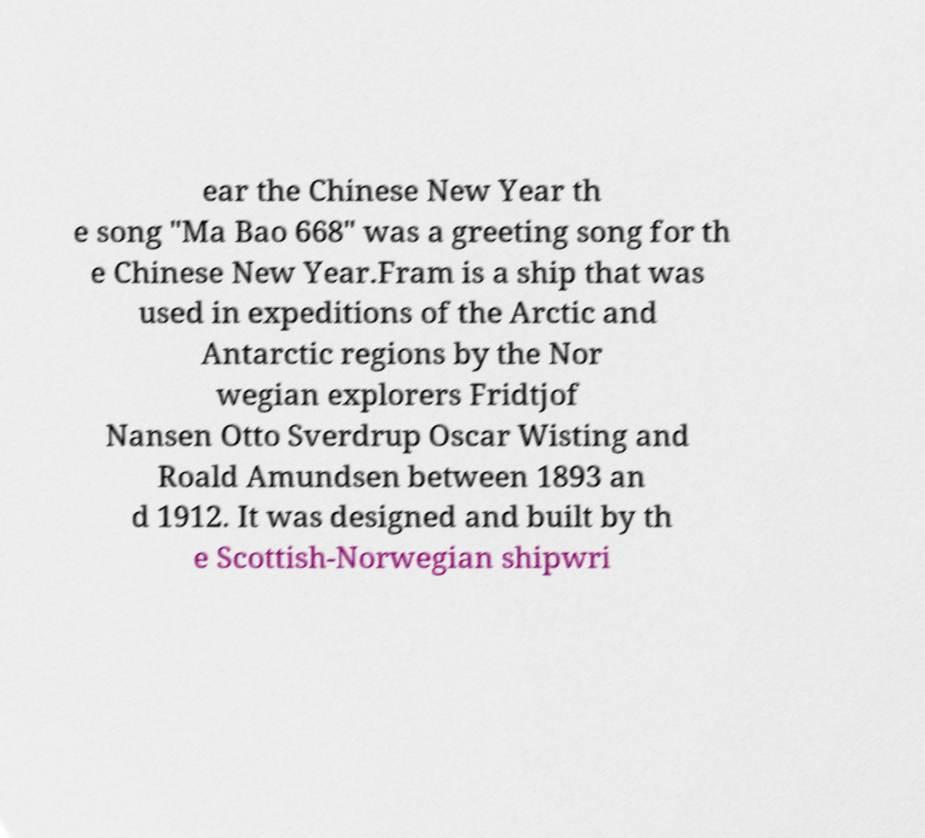There's text embedded in this image that I need extracted. Can you transcribe it verbatim? ear the Chinese New Year th e song "Ma Bao 668" was a greeting song for th e Chinese New Year.Fram is a ship that was used in expeditions of the Arctic and Antarctic regions by the Nor wegian explorers Fridtjof Nansen Otto Sverdrup Oscar Wisting and Roald Amundsen between 1893 an d 1912. It was designed and built by th e Scottish-Norwegian shipwri 